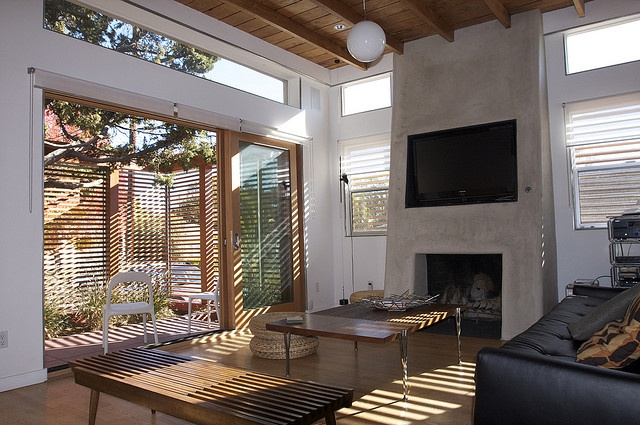Describe the objects in this image and their specific colors. I can see couch in gray, black, and maroon tones, bench in gray, black, and maroon tones, tv in gray and black tones, dining table in gray, black, and maroon tones, and chair in gray tones in this image. 